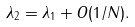<formula> <loc_0><loc_0><loc_500><loc_500>\lambda _ { 2 } = \lambda _ { 1 } + O ( 1 / N ) .</formula> 